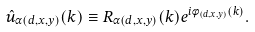<formula> <loc_0><loc_0><loc_500><loc_500>\hat { u } _ { \alpha ( d , x , y ) } ( k ) \equiv R _ { \alpha ( d , x , y ) } ( k ) e ^ { i \phi _ { ( d , x , y ) } ( k ) } .</formula> 